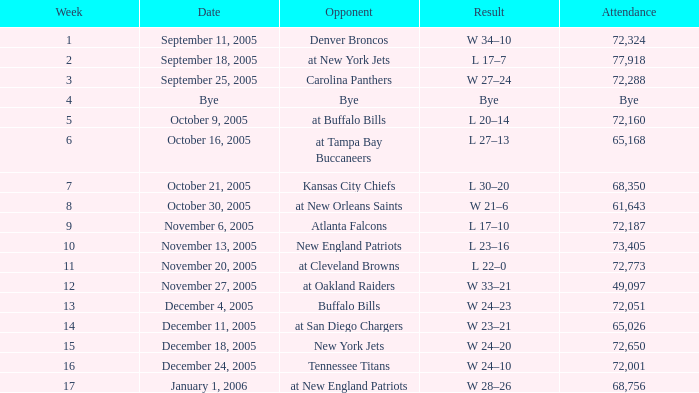On what Date was the Attendance 73,405? November 13, 2005. 